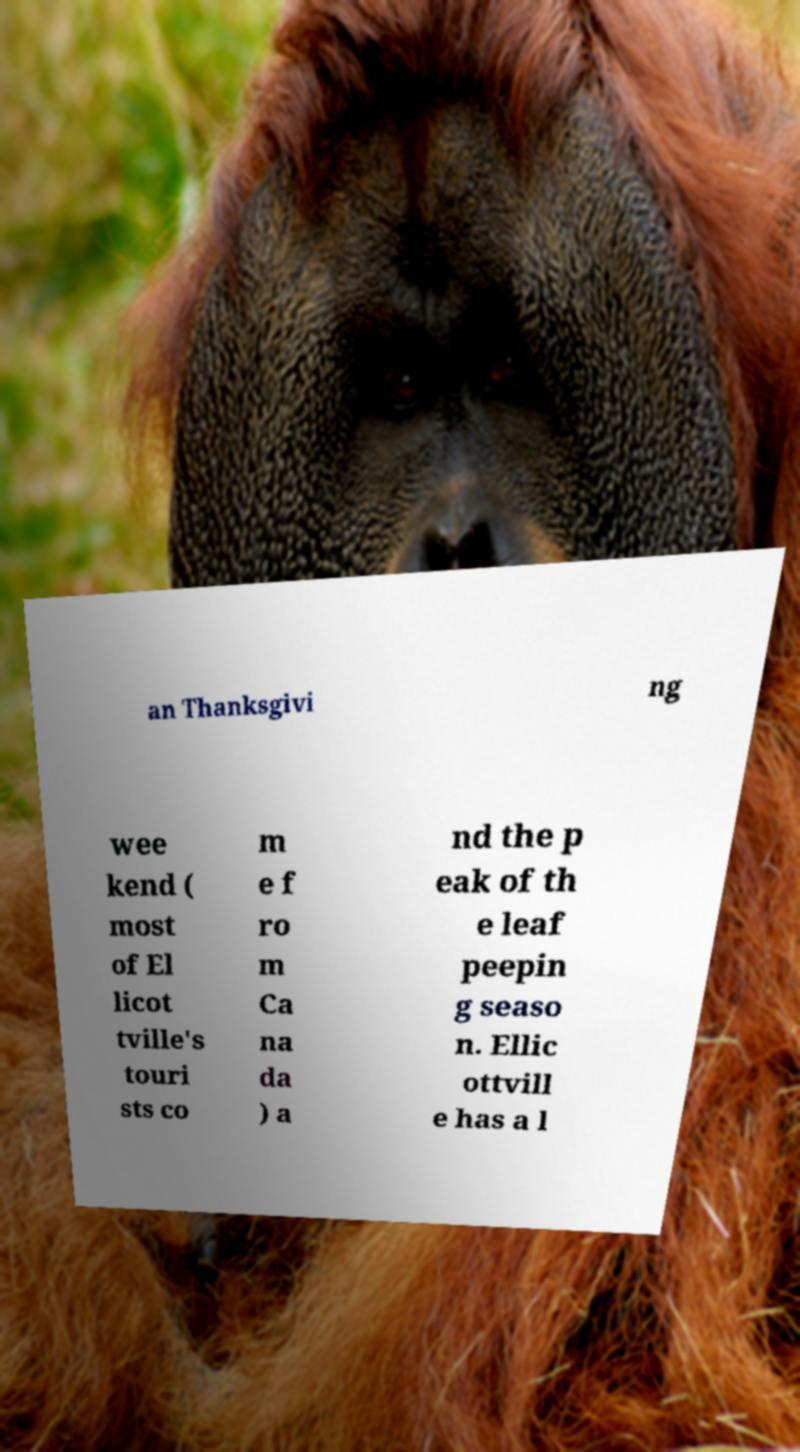Can you read and provide the text displayed in the image?This photo seems to have some interesting text. Can you extract and type it out for me? an Thanksgivi ng wee kend ( most of El licot tville's touri sts co m e f ro m Ca na da ) a nd the p eak of th e leaf peepin g seaso n. Ellic ottvill e has a l 